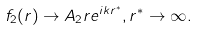Convert formula to latex. <formula><loc_0><loc_0><loc_500><loc_500>f _ { 2 } ( r ) \rightarrow A _ { 2 } r e ^ { i k r ^ { * } } , r ^ { * } \rightarrow \infty .</formula> 